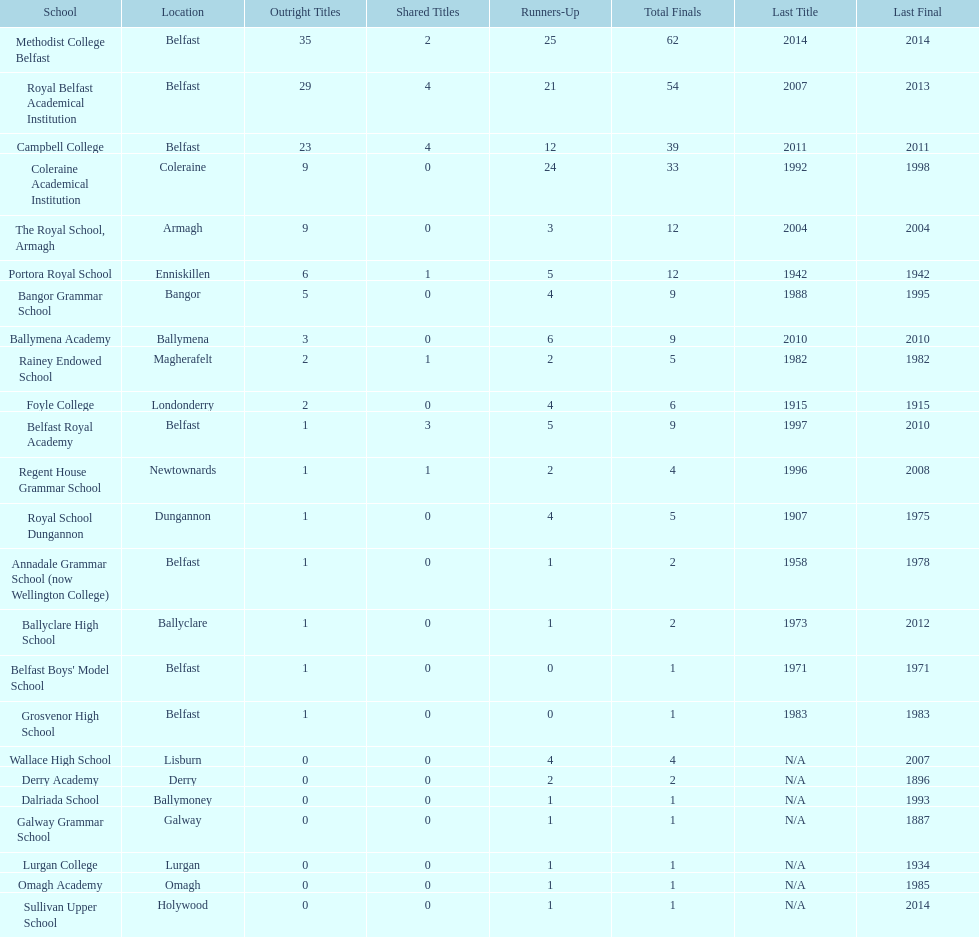When was the most recent year the regent house grammar school claimed a title? 1996. 